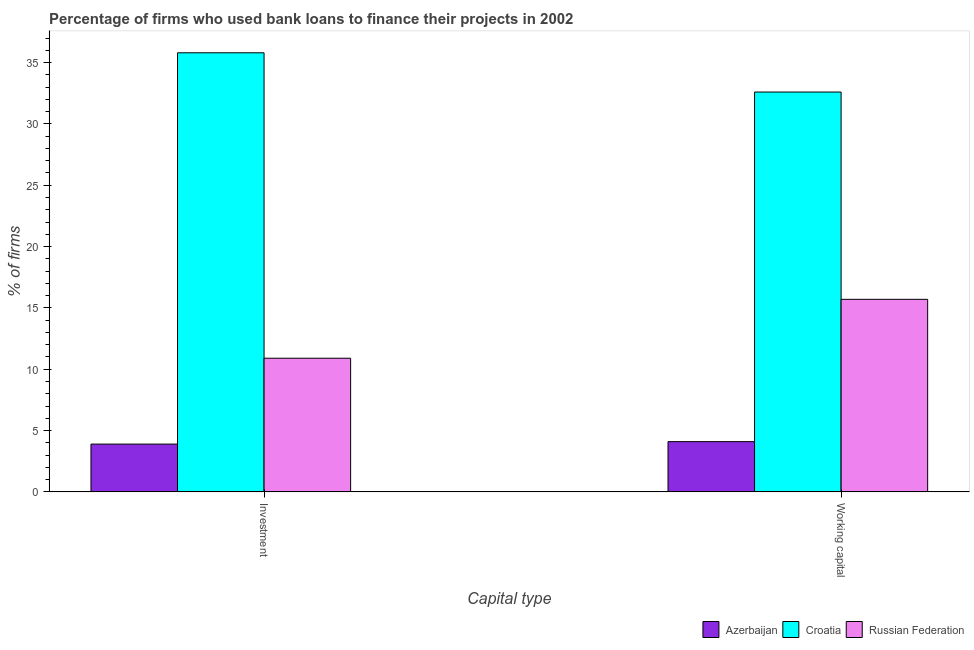How many groups of bars are there?
Provide a short and direct response. 2. How many bars are there on the 1st tick from the left?
Offer a terse response. 3. What is the label of the 1st group of bars from the left?
Offer a terse response. Investment. Across all countries, what is the maximum percentage of firms using banks to finance investment?
Ensure brevity in your answer.  35.8. Across all countries, what is the minimum percentage of firms using banks to finance working capital?
Your response must be concise. 4.1. In which country was the percentage of firms using banks to finance investment maximum?
Make the answer very short. Croatia. In which country was the percentage of firms using banks to finance investment minimum?
Give a very brief answer. Azerbaijan. What is the total percentage of firms using banks to finance investment in the graph?
Provide a succinct answer. 50.6. What is the difference between the percentage of firms using banks to finance investment in Azerbaijan and that in Croatia?
Your answer should be compact. -31.9. What is the difference between the percentage of firms using banks to finance investment in Azerbaijan and the percentage of firms using banks to finance working capital in Russian Federation?
Provide a short and direct response. -11.8. What is the average percentage of firms using banks to finance working capital per country?
Your answer should be very brief. 17.47. What is the difference between the percentage of firms using banks to finance investment and percentage of firms using banks to finance working capital in Azerbaijan?
Ensure brevity in your answer.  -0.2. In how many countries, is the percentage of firms using banks to finance investment greater than 9 %?
Give a very brief answer. 2. What is the ratio of the percentage of firms using banks to finance working capital in Croatia to that in Russian Federation?
Provide a succinct answer. 2.08. In how many countries, is the percentage of firms using banks to finance investment greater than the average percentage of firms using banks to finance investment taken over all countries?
Offer a terse response. 1. What does the 3rd bar from the left in Working capital represents?
Make the answer very short. Russian Federation. What does the 2nd bar from the right in Investment represents?
Provide a succinct answer. Croatia. Are all the bars in the graph horizontal?
Your response must be concise. No. What is the difference between two consecutive major ticks on the Y-axis?
Your response must be concise. 5. Does the graph contain grids?
Make the answer very short. No. What is the title of the graph?
Your answer should be very brief. Percentage of firms who used bank loans to finance their projects in 2002. What is the label or title of the X-axis?
Your answer should be compact. Capital type. What is the label or title of the Y-axis?
Offer a very short reply. % of firms. What is the % of firms of Croatia in Investment?
Ensure brevity in your answer.  35.8. What is the % of firms of Russian Federation in Investment?
Provide a short and direct response. 10.9. What is the % of firms in Croatia in Working capital?
Your answer should be compact. 32.6. Across all Capital type, what is the maximum % of firms in Azerbaijan?
Offer a very short reply. 4.1. Across all Capital type, what is the maximum % of firms in Croatia?
Your response must be concise. 35.8. Across all Capital type, what is the minimum % of firms in Croatia?
Provide a succinct answer. 32.6. Across all Capital type, what is the minimum % of firms of Russian Federation?
Offer a terse response. 10.9. What is the total % of firms of Croatia in the graph?
Your response must be concise. 68.4. What is the total % of firms of Russian Federation in the graph?
Your response must be concise. 26.6. What is the difference between the % of firms in Azerbaijan in Investment and that in Working capital?
Your answer should be very brief. -0.2. What is the difference between the % of firms of Russian Federation in Investment and that in Working capital?
Your answer should be compact. -4.8. What is the difference between the % of firms in Azerbaijan in Investment and the % of firms in Croatia in Working capital?
Keep it short and to the point. -28.7. What is the difference between the % of firms in Croatia in Investment and the % of firms in Russian Federation in Working capital?
Ensure brevity in your answer.  20.1. What is the average % of firms in Azerbaijan per Capital type?
Your answer should be very brief. 4. What is the average % of firms of Croatia per Capital type?
Keep it short and to the point. 34.2. What is the difference between the % of firms of Azerbaijan and % of firms of Croatia in Investment?
Your answer should be very brief. -31.9. What is the difference between the % of firms of Azerbaijan and % of firms of Russian Federation in Investment?
Ensure brevity in your answer.  -7. What is the difference between the % of firms in Croatia and % of firms in Russian Federation in Investment?
Your answer should be very brief. 24.9. What is the difference between the % of firms of Azerbaijan and % of firms of Croatia in Working capital?
Provide a short and direct response. -28.5. What is the ratio of the % of firms in Azerbaijan in Investment to that in Working capital?
Make the answer very short. 0.95. What is the ratio of the % of firms in Croatia in Investment to that in Working capital?
Offer a very short reply. 1.1. What is the ratio of the % of firms of Russian Federation in Investment to that in Working capital?
Ensure brevity in your answer.  0.69. What is the difference between the highest and the second highest % of firms in Croatia?
Your answer should be very brief. 3.2. What is the difference between the highest and the second highest % of firms in Russian Federation?
Make the answer very short. 4.8. What is the difference between the highest and the lowest % of firms of Azerbaijan?
Offer a very short reply. 0.2. What is the difference between the highest and the lowest % of firms of Croatia?
Ensure brevity in your answer.  3.2. What is the difference between the highest and the lowest % of firms in Russian Federation?
Make the answer very short. 4.8. 